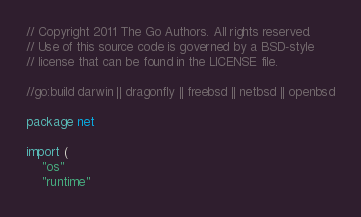<code> <loc_0><loc_0><loc_500><loc_500><_Go_>// Copyright 2011 The Go Authors. All rights reserved.
// Use of this source code is governed by a BSD-style
// license that can be found in the LICENSE file.

//go:build darwin || dragonfly || freebsd || netbsd || openbsd

package net

import (
	"os"
	"runtime"</code> 